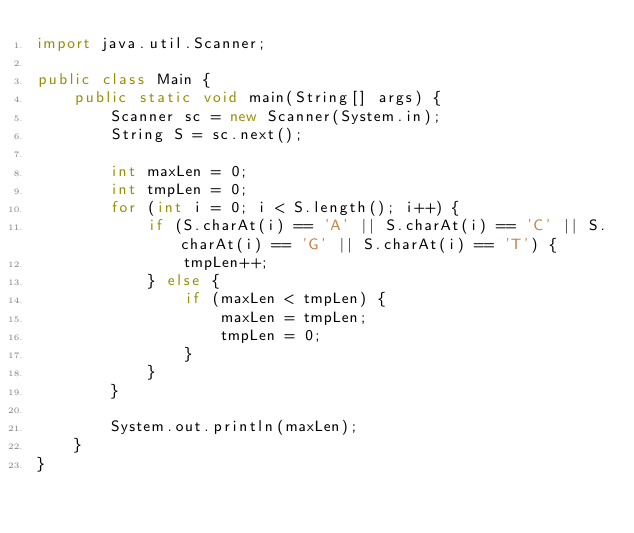Convert code to text. <code><loc_0><loc_0><loc_500><loc_500><_Java_>import java.util.Scanner;

public class Main {
    public static void main(String[] args) {
        Scanner sc = new Scanner(System.in);
        String S = sc.next();

        int maxLen = 0;
        int tmpLen = 0;
        for (int i = 0; i < S.length(); i++) {
            if (S.charAt(i) == 'A' || S.charAt(i) == 'C' || S.charAt(i) == 'G' || S.charAt(i) == 'T') {
                tmpLen++;
            } else {
                if (maxLen < tmpLen) {
                    maxLen = tmpLen;
                    tmpLen = 0;
                }
            }
        }

        System.out.println(maxLen);
    }
}
</code> 